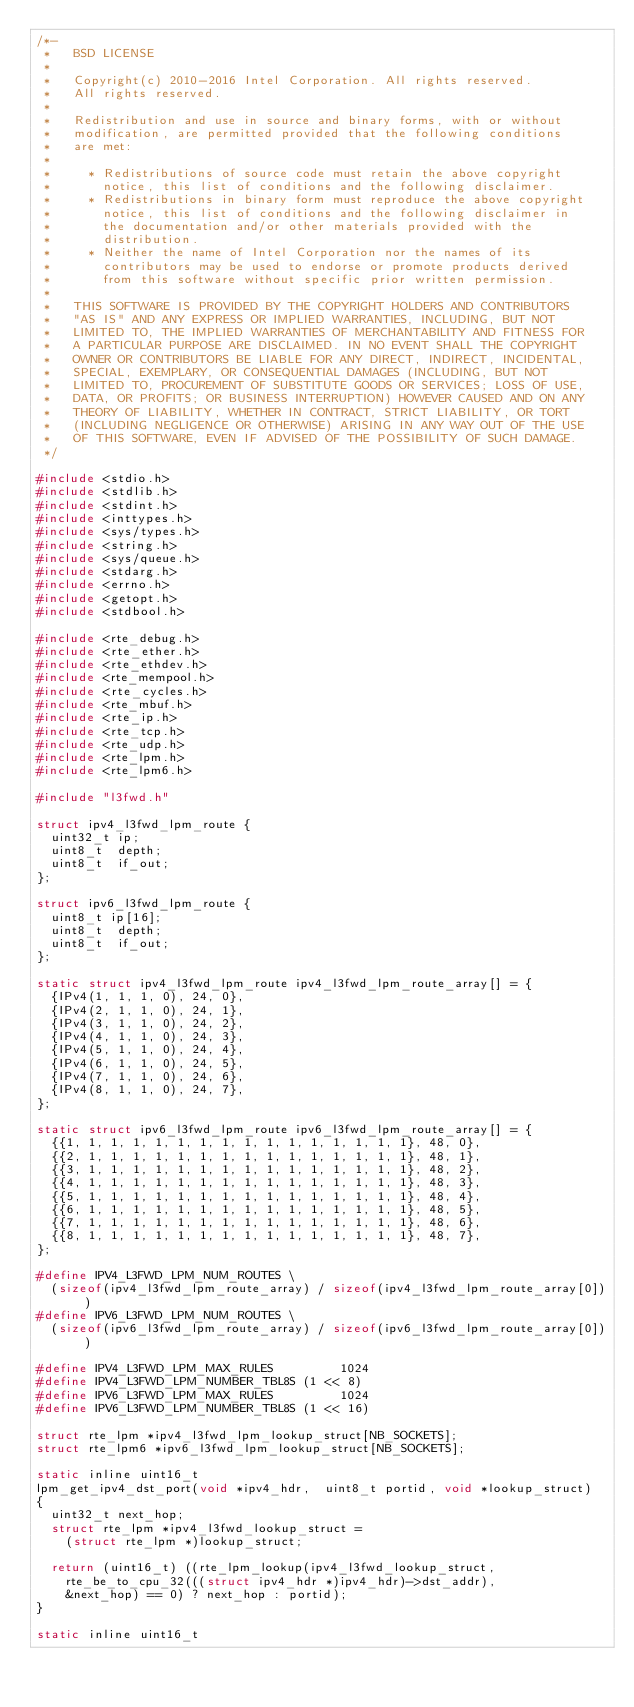<code> <loc_0><loc_0><loc_500><loc_500><_C_>/*-
 *   BSD LICENSE
 *
 *   Copyright(c) 2010-2016 Intel Corporation. All rights reserved.
 *   All rights reserved.
 *
 *   Redistribution and use in source and binary forms, with or without
 *   modification, are permitted provided that the following conditions
 *   are met:
 *
 *     * Redistributions of source code must retain the above copyright
 *       notice, this list of conditions and the following disclaimer.
 *     * Redistributions in binary form must reproduce the above copyright
 *       notice, this list of conditions and the following disclaimer in
 *       the documentation and/or other materials provided with the
 *       distribution.
 *     * Neither the name of Intel Corporation nor the names of its
 *       contributors may be used to endorse or promote products derived
 *       from this software without specific prior written permission.
 *
 *   THIS SOFTWARE IS PROVIDED BY THE COPYRIGHT HOLDERS AND CONTRIBUTORS
 *   "AS IS" AND ANY EXPRESS OR IMPLIED WARRANTIES, INCLUDING, BUT NOT
 *   LIMITED TO, THE IMPLIED WARRANTIES OF MERCHANTABILITY AND FITNESS FOR
 *   A PARTICULAR PURPOSE ARE DISCLAIMED. IN NO EVENT SHALL THE COPYRIGHT
 *   OWNER OR CONTRIBUTORS BE LIABLE FOR ANY DIRECT, INDIRECT, INCIDENTAL,
 *   SPECIAL, EXEMPLARY, OR CONSEQUENTIAL DAMAGES (INCLUDING, BUT NOT
 *   LIMITED TO, PROCUREMENT OF SUBSTITUTE GOODS OR SERVICES; LOSS OF USE,
 *   DATA, OR PROFITS; OR BUSINESS INTERRUPTION) HOWEVER CAUSED AND ON ANY
 *   THEORY OF LIABILITY, WHETHER IN CONTRACT, STRICT LIABILITY, OR TORT
 *   (INCLUDING NEGLIGENCE OR OTHERWISE) ARISING IN ANY WAY OUT OF THE USE
 *   OF THIS SOFTWARE, EVEN IF ADVISED OF THE POSSIBILITY OF SUCH DAMAGE.
 */

#include <stdio.h>
#include <stdlib.h>
#include <stdint.h>
#include <inttypes.h>
#include <sys/types.h>
#include <string.h>
#include <sys/queue.h>
#include <stdarg.h>
#include <errno.h>
#include <getopt.h>
#include <stdbool.h>

#include <rte_debug.h>
#include <rte_ether.h>
#include <rte_ethdev.h>
#include <rte_mempool.h>
#include <rte_cycles.h>
#include <rte_mbuf.h>
#include <rte_ip.h>
#include <rte_tcp.h>
#include <rte_udp.h>
#include <rte_lpm.h>
#include <rte_lpm6.h>

#include "l3fwd.h"

struct ipv4_l3fwd_lpm_route {
	uint32_t ip;
	uint8_t  depth;
	uint8_t  if_out;
};

struct ipv6_l3fwd_lpm_route {
	uint8_t ip[16];
	uint8_t  depth;
	uint8_t  if_out;
};

static struct ipv4_l3fwd_lpm_route ipv4_l3fwd_lpm_route_array[] = {
	{IPv4(1, 1, 1, 0), 24, 0},
	{IPv4(2, 1, 1, 0), 24, 1},
	{IPv4(3, 1, 1, 0), 24, 2},
	{IPv4(4, 1, 1, 0), 24, 3},
	{IPv4(5, 1, 1, 0), 24, 4},
	{IPv4(6, 1, 1, 0), 24, 5},
	{IPv4(7, 1, 1, 0), 24, 6},
	{IPv4(8, 1, 1, 0), 24, 7},
};

static struct ipv6_l3fwd_lpm_route ipv6_l3fwd_lpm_route_array[] = {
	{{1, 1, 1, 1, 1, 1, 1, 1, 1, 1, 1, 1, 1, 1, 1, 1}, 48, 0},
	{{2, 1, 1, 1, 1, 1, 1, 1, 1, 1, 1, 1, 1, 1, 1, 1}, 48, 1},
	{{3, 1, 1, 1, 1, 1, 1, 1, 1, 1, 1, 1, 1, 1, 1, 1}, 48, 2},
	{{4, 1, 1, 1, 1, 1, 1, 1, 1, 1, 1, 1, 1, 1, 1, 1}, 48, 3},
	{{5, 1, 1, 1, 1, 1, 1, 1, 1, 1, 1, 1, 1, 1, 1, 1}, 48, 4},
	{{6, 1, 1, 1, 1, 1, 1, 1, 1, 1, 1, 1, 1, 1, 1, 1}, 48, 5},
	{{7, 1, 1, 1, 1, 1, 1, 1, 1, 1, 1, 1, 1, 1, 1, 1}, 48, 6},
	{{8, 1, 1, 1, 1, 1, 1, 1, 1, 1, 1, 1, 1, 1, 1, 1}, 48, 7},
};

#define IPV4_L3FWD_LPM_NUM_ROUTES \
	(sizeof(ipv4_l3fwd_lpm_route_array) / sizeof(ipv4_l3fwd_lpm_route_array[0]))
#define IPV6_L3FWD_LPM_NUM_ROUTES \
	(sizeof(ipv6_l3fwd_lpm_route_array) / sizeof(ipv6_l3fwd_lpm_route_array[0]))

#define IPV4_L3FWD_LPM_MAX_RULES         1024
#define IPV4_L3FWD_LPM_NUMBER_TBL8S (1 << 8)
#define IPV6_L3FWD_LPM_MAX_RULES         1024
#define IPV6_L3FWD_LPM_NUMBER_TBL8S (1 << 16)

struct rte_lpm *ipv4_l3fwd_lpm_lookup_struct[NB_SOCKETS];
struct rte_lpm6 *ipv6_l3fwd_lpm_lookup_struct[NB_SOCKETS];

static inline uint16_t
lpm_get_ipv4_dst_port(void *ipv4_hdr,  uint8_t portid, void *lookup_struct)
{
	uint32_t next_hop;
	struct rte_lpm *ipv4_l3fwd_lookup_struct =
		(struct rte_lpm *)lookup_struct;

	return (uint16_t) ((rte_lpm_lookup(ipv4_l3fwd_lookup_struct,
		rte_be_to_cpu_32(((struct ipv4_hdr *)ipv4_hdr)->dst_addr),
		&next_hop) == 0) ? next_hop : portid);
}

static inline uint16_t</code> 